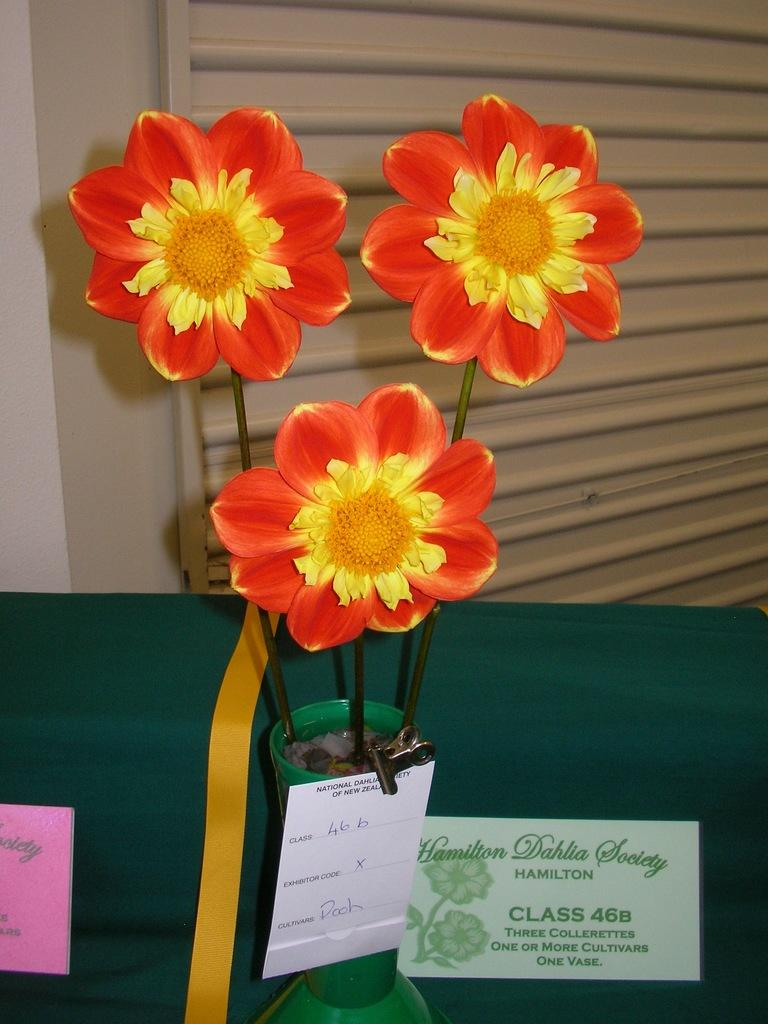What type of decorative items are in the vase in the image? There are artificial flowers in a vase in the image. What other objects can be seen in the image? There are name boards in the image. What can be seen in the background of the image? There is a shutter visible in the background of the image. What is the purpose of the boy in the image? There is no boy present in the image, so it is not possible to determine the purpose of a boy. 